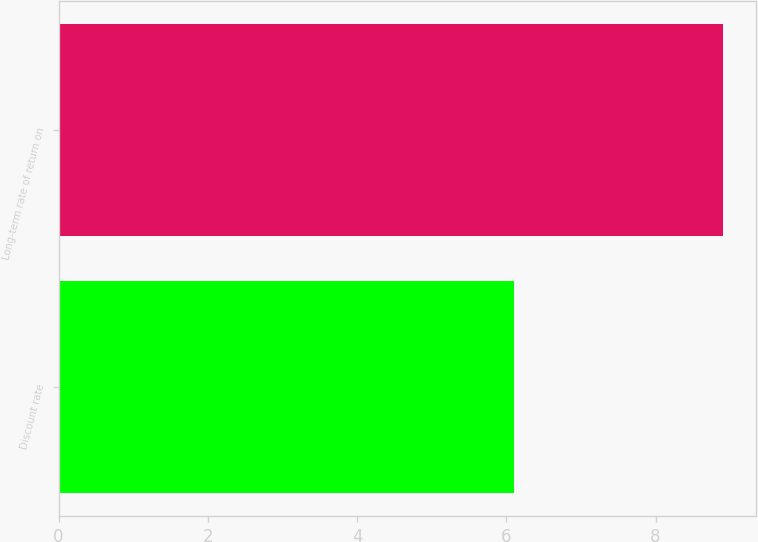Convert chart to OTSL. <chart><loc_0><loc_0><loc_500><loc_500><bar_chart><fcel>Discount rate<fcel>Long-term rate of return on<nl><fcel>6.1<fcel>8.9<nl></chart> 